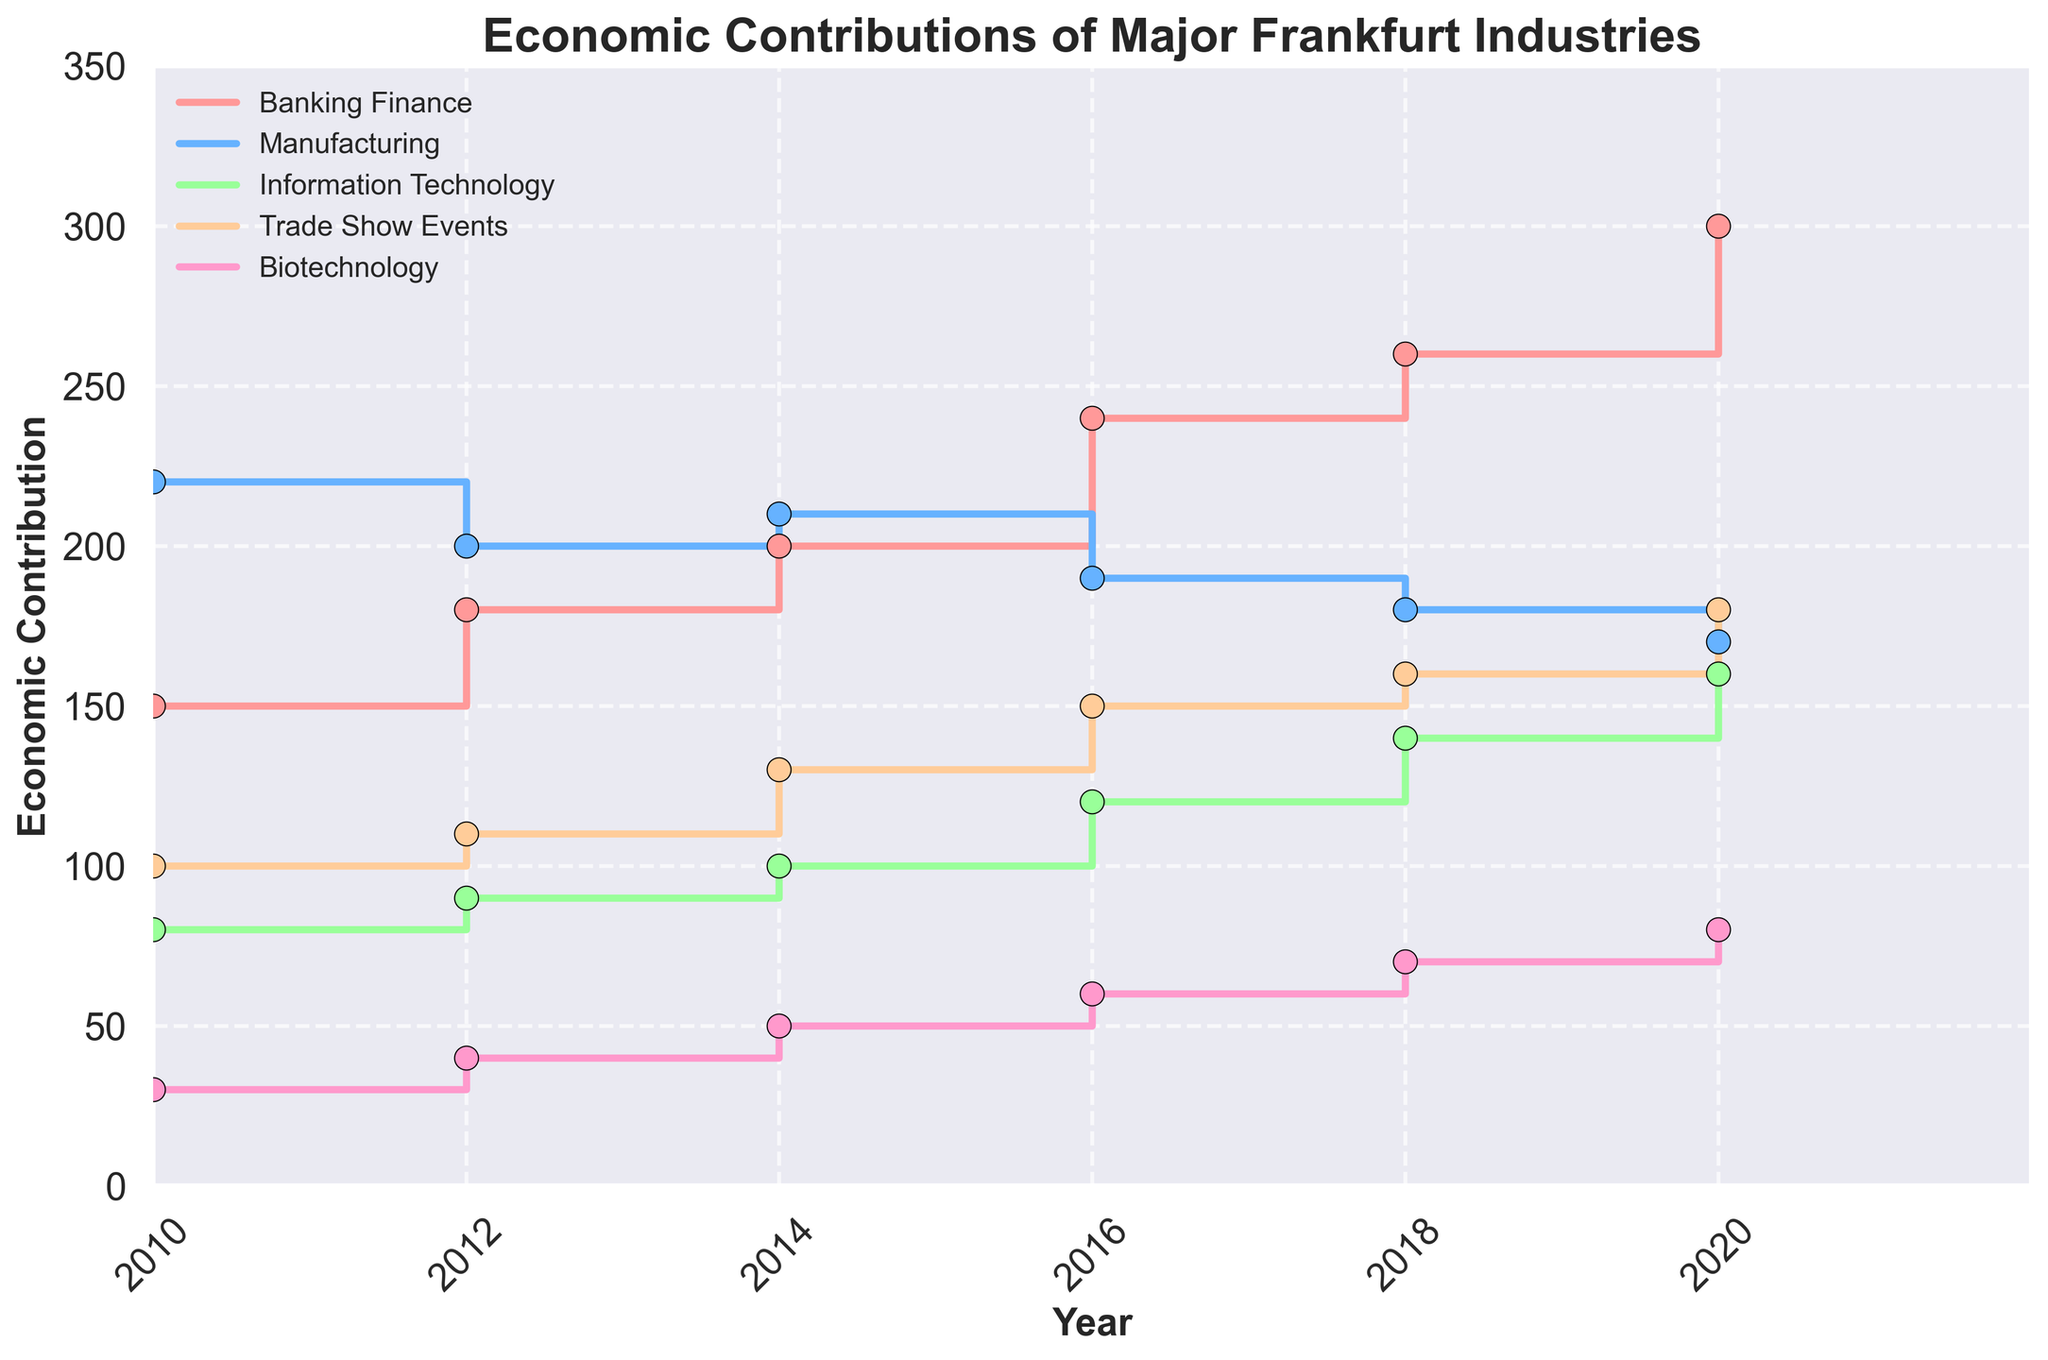What is the title of the figure? The title of the figure is displayed at the top and provides an overview of what the data represents.
Answer: Economic Contributions of Major Frankfurt Industries What is the economic contribution of Information Technology in 2018-2020? Locate the 'Information Technology' line on the figure, then find the value at the step corresponding to the years 2018-2020.
Answer: 140 Which industry had the highest economic contribution in 2020-2022? Compare the final step values for all industries in the years 2020-2022 and identify the highest one.
Answer: Banking Finance What is the difference in economic contribution between Biotechnology and Manufacturing in 2016-2018? Find the values for both Biotechnology and Manufacturing for the years 2016-2018 and subtract the contribution of Biotechnology from Manufacturing.
Answer: 130 How many vertical steps are there for the Banking and Finance data? Count the number of distinct vertical steps in the Banking and Finance line.
Answer: 6 During which year range did Trade Show Events see the largest increase in economic contribution? Identify the year range where the Trade Show Events line has the steepest upward step.
Answer: 2014-2016 Is the economic contribution of Information Technology in 2018-2020 greater than that of Manufacturing in the same years? Compare the step values of Information Technology and Manufacturing in 2018-2020.
Answer: Yes Which two industries had the closest economic contributions in 2018-2020? Look for the two lines that are closest to each other vertically in the years 2018-2020.
Answer: Trade Show Events and Information Technology What is the average economic contribution of Biotechnology across all displayed years? Calculate the average by adding all the contributions of Biotechnology from year 2010 to 2022 and divide by the number of data points.
Answer: 55 In which year range did Banking Finance surpass the 250 economic contribution mark? Find the year where the Banking Finance line first exceeds a value of 250.
Answer: 2018-2020 